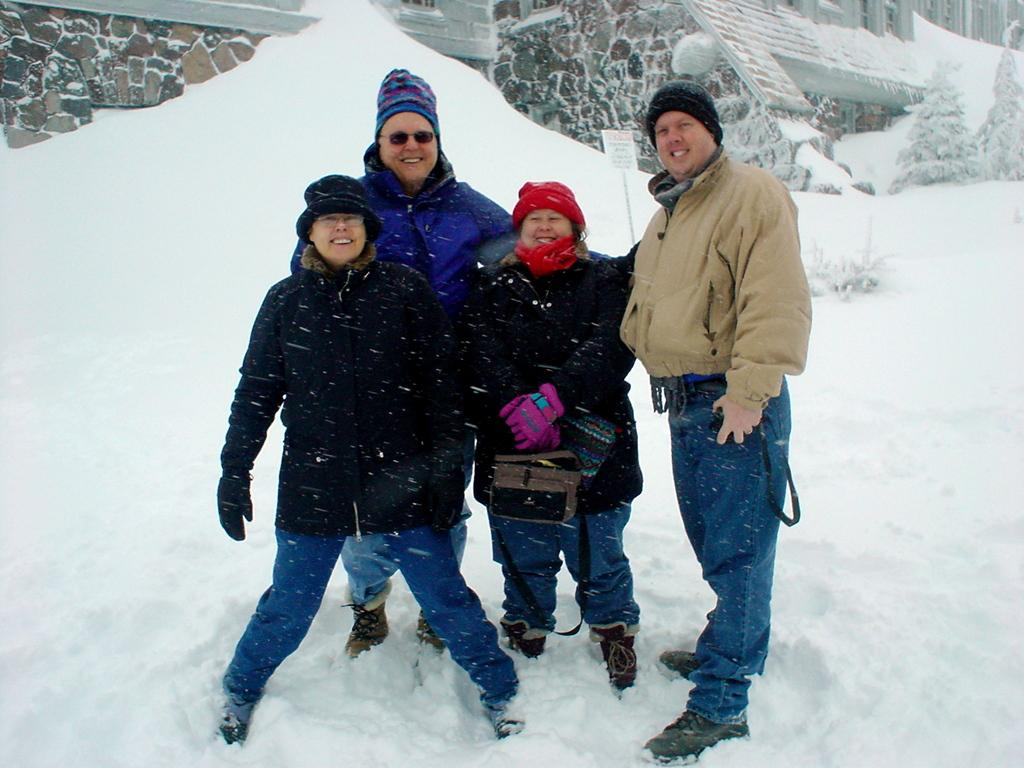What is the surface on which the people are standing in the image? The people are standing on snow in the image. What is one person holding in the image? One person is holding a bag in the image. What can be seen in the background of the image? There is a name board, plants, and buildings in the background of the image. What type of leaf is being stored in the jar on the ground in the image? There is no jar or leaf present in the image. What kind of insect can be seen crawling on the person holding the bag in the image? There are no insects visible on the person holding the bag in the image. 